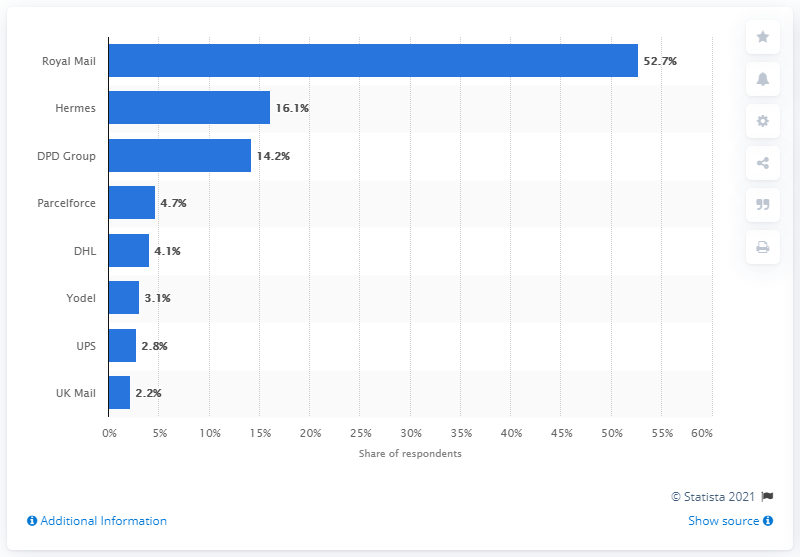List a handful of essential elements in this visual. 52.7% of respondents indicated that they would choose the long-standing UK-based courier company. 